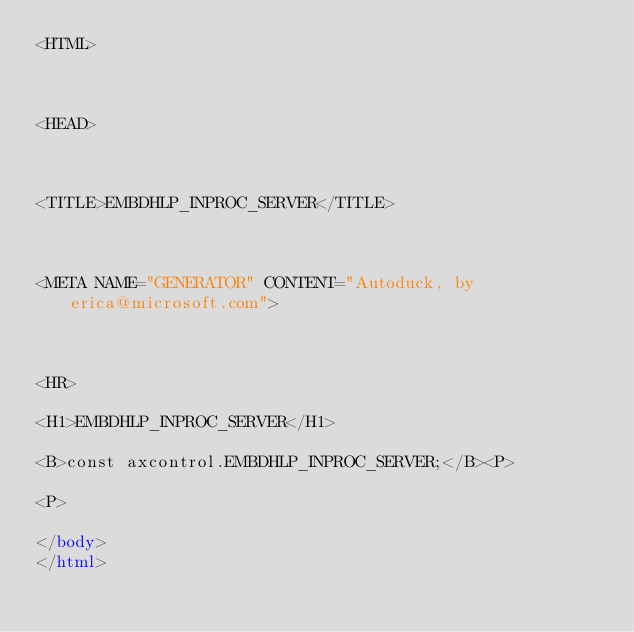Convert code to text. <code><loc_0><loc_0><loc_500><loc_500><_HTML_><HTML>



<HEAD>



<TITLE>EMBDHLP_INPROC_SERVER</TITLE>



<META NAME="GENERATOR" CONTENT="Autoduck, by erica@microsoft.com">



<HR>

<H1>EMBDHLP_INPROC_SERVER</H1>

<B>const axcontrol.EMBDHLP_INPROC_SERVER;</B><P>

<P>

</body>
</html></code> 